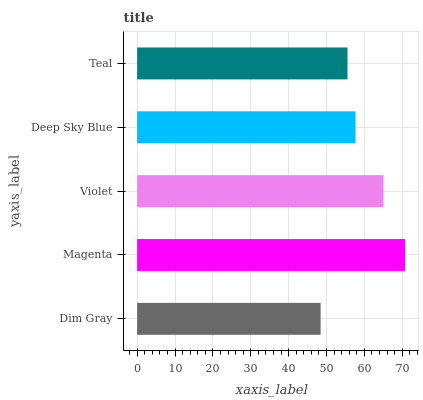Is Dim Gray the minimum?
Answer yes or no. Yes. Is Magenta the maximum?
Answer yes or no. Yes. Is Violet the minimum?
Answer yes or no. No. Is Violet the maximum?
Answer yes or no. No. Is Magenta greater than Violet?
Answer yes or no. Yes. Is Violet less than Magenta?
Answer yes or no. Yes. Is Violet greater than Magenta?
Answer yes or no. No. Is Magenta less than Violet?
Answer yes or no. No. Is Deep Sky Blue the high median?
Answer yes or no. Yes. Is Deep Sky Blue the low median?
Answer yes or no. Yes. Is Dim Gray the high median?
Answer yes or no. No. Is Magenta the low median?
Answer yes or no. No. 